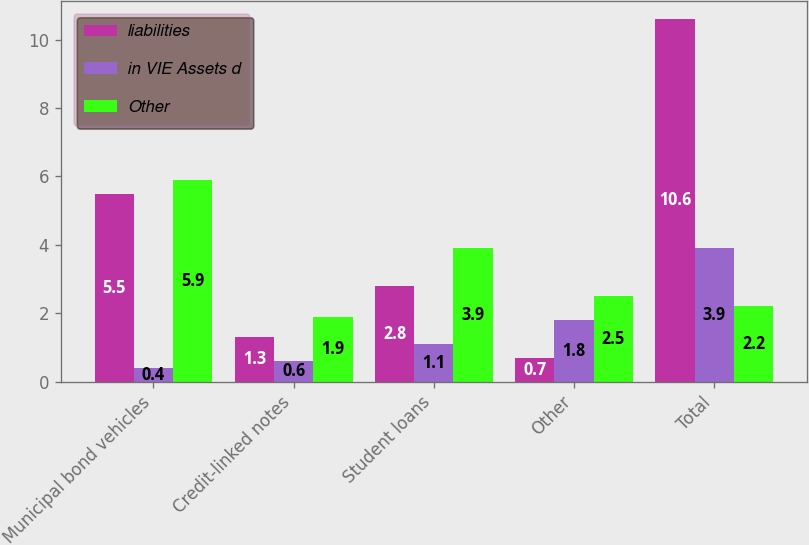<chart> <loc_0><loc_0><loc_500><loc_500><stacked_bar_chart><ecel><fcel>Municipal bond vehicles<fcel>Credit-linked notes<fcel>Student loans<fcel>Other<fcel>Total<nl><fcel>liabilities<fcel>5.5<fcel>1.3<fcel>2.8<fcel>0.7<fcel>10.6<nl><fcel>in VIE Assets d<fcel>0.4<fcel>0.6<fcel>1.1<fcel>1.8<fcel>3.9<nl><fcel>Other<fcel>5.9<fcel>1.9<fcel>3.9<fcel>2.5<fcel>2.2<nl></chart> 